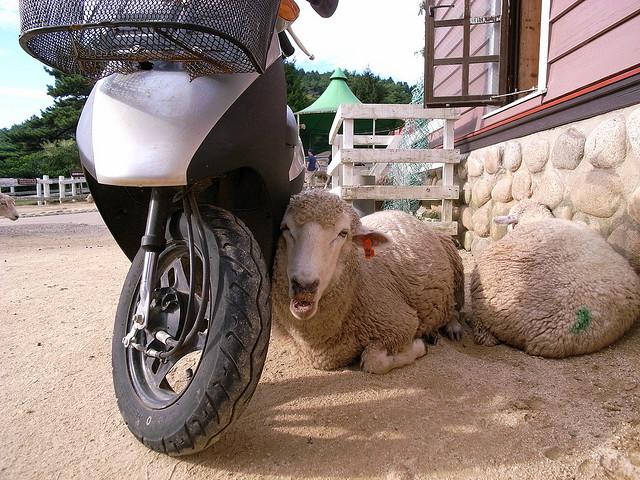Is the sheep afraid of the motorcycle?
Short answer required. No. What color is the motorcycle?
Write a very short answer. Silver. Is there a basket on the motorcycle?
Give a very brief answer. Yes. 